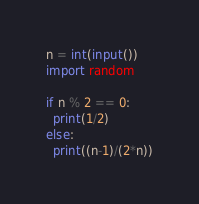Convert code to text. <code><loc_0><loc_0><loc_500><loc_500><_Python_>n = int(input())
import random
 
if n % 2 == 0:
  print(1/2)
else:
  print((n-1)/(2*n))</code> 